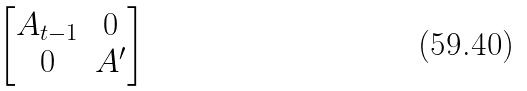Convert formula to latex. <formula><loc_0><loc_0><loc_500><loc_500>\begin{bmatrix} A _ { t - 1 } & 0 \\ 0 & A ^ { \prime } \end{bmatrix}</formula> 